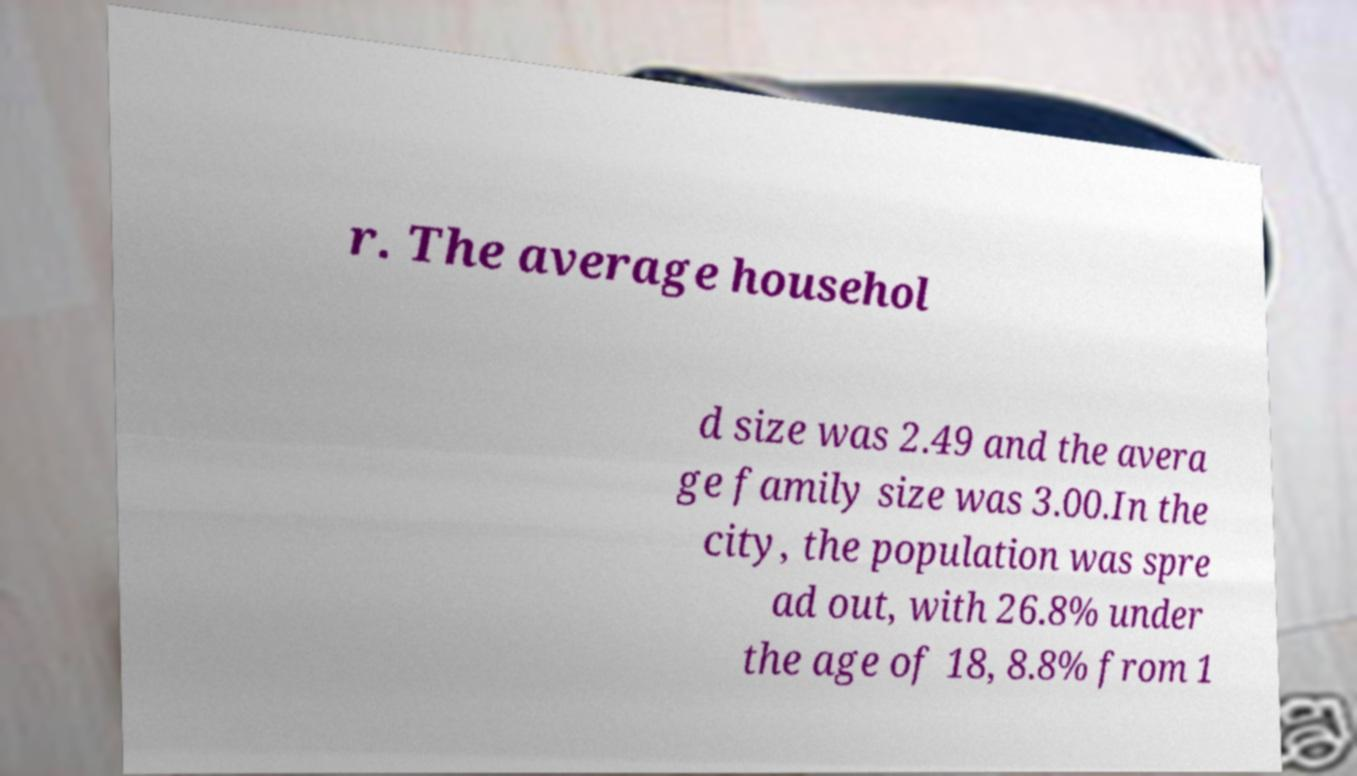Please identify and transcribe the text found in this image. r. The average househol d size was 2.49 and the avera ge family size was 3.00.In the city, the population was spre ad out, with 26.8% under the age of 18, 8.8% from 1 